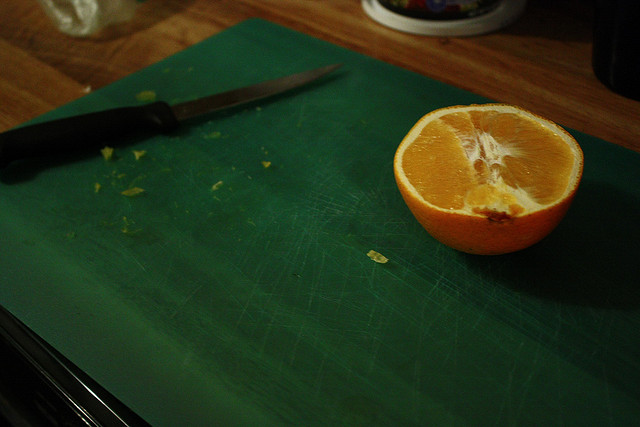What kind of orange is this?
Answer the question using a single word or phrase. Navel 